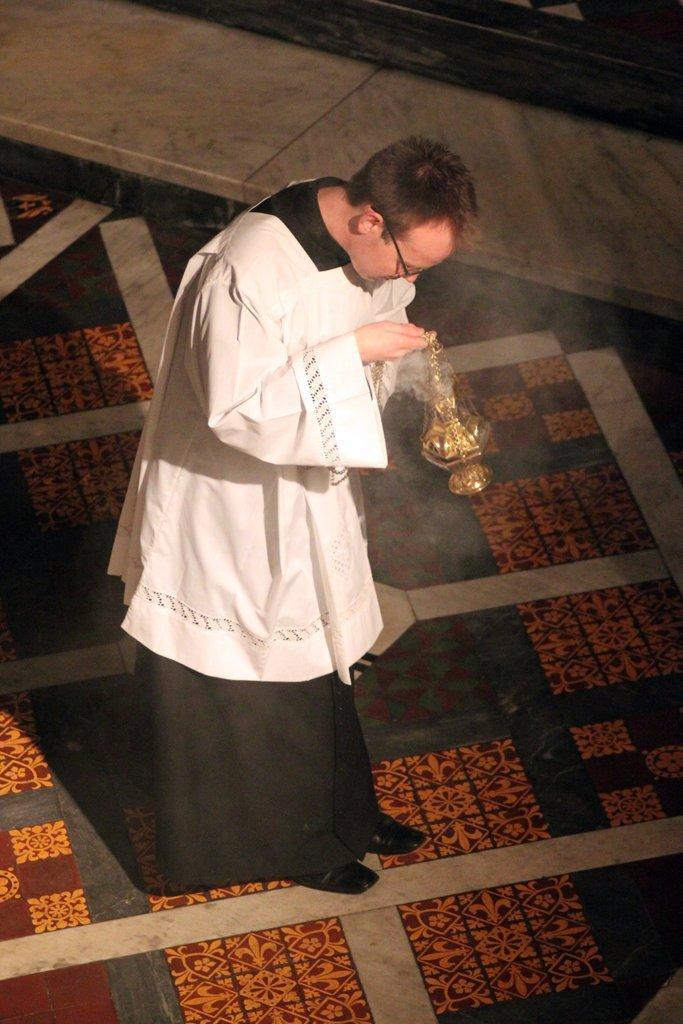Can you describe this image briefly? In this picture we can see a man wore a spectacle and holding an object with his hands and standing on the floor. 